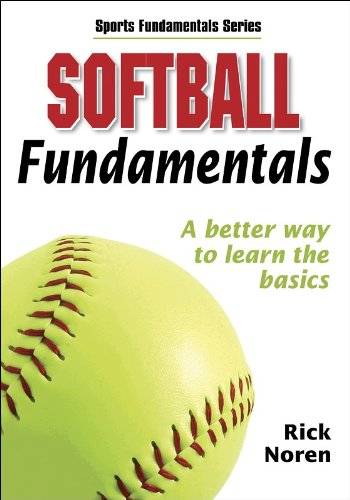Who wrote this book? The book 'Softball Fundamentals' was written by Human Kinetics. 